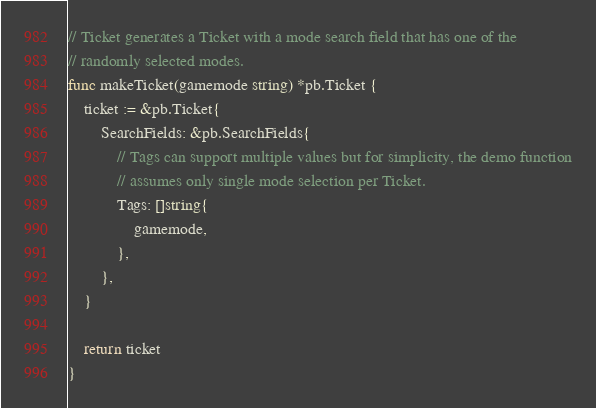<code> <loc_0><loc_0><loc_500><loc_500><_Go_>
// Ticket generates a Ticket with a mode search field that has one of the
// randomly selected modes.
func makeTicket(gamemode string) *pb.Ticket {
	ticket := &pb.Ticket{
		SearchFields: &pb.SearchFields{
			// Tags can support multiple values but for simplicity, the demo function
			// assumes only single mode selection per Ticket.
			Tags: []string{
				gamemode,
			},
		},
	}

	return ticket
}
</code> 